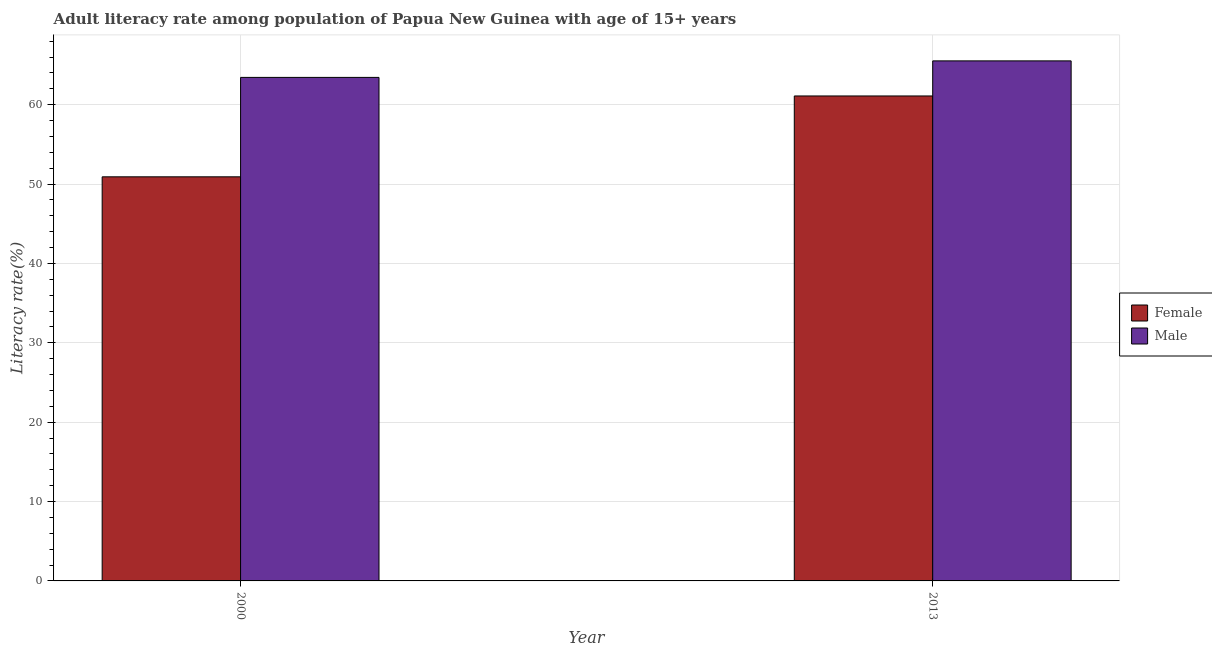How many groups of bars are there?
Your response must be concise. 2. Are the number of bars per tick equal to the number of legend labels?
Your answer should be very brief. Yes. Are the number of bars on each tick of the X-axis equal?
Your answer should be compact. Yes. In how many cases, is the number of bars for a given year not equal to the number of legend labels?
Provide a succinct answer. 0. What is the female adult literacy rate in 2000?
Your answer should be very brief. 50.92. Across all years, what is the maximum male adult literacy rate?
Provide a succinct answer. 65.53. Across all years, what is the minimum female adult literacy rate?
Provide a succinct answer. 50.92. In which year was the male adult literacy rate maximum?
Offer a terse response. 2013. What is the total male adult literacy rate in the graph?
Offer a terse response. 128.97. What is the difference between the female adult literacy rate in 2000 and that in 2013?
Make the answer very short. -10.19. What is the difference between the male adult literacy rate in 2013 and the female adult literacy rate in 2000?
Your answer should be compact. 2.08. What is the average female adult literacy rate per year?
Offer a very short reply. 56.01. In how many years, is the female adult literacy rate greater than 42 %?
Make the answer very short. 2. What is the ratio of the male adult literacy rate in 2000 to that in 2013?
Offer a very short reply. 0.97. What does the 2nd bar from the right in 2000 represents?
Your response must be concise. Female. How many bars are there?
Offer a terse response. 4. How many years are there in the graph?
Your answer should be very brief. 2. Are the values on the major ticks of Y-axis written in scientific E-notation?
Your response must be concise. No. Does the graph contain grids?
Your answer should be very brief. Yes. How many legend labels are there?
Provide a succinct answer. 2. How are the legend labels stacked?
Ensure brevity in your answer.  Vertical. What is the title of the graph?
Your answer should be compact. Adult literacy rate among population of Papua New Guinea with age of 15+ years. Does "Nonresident" appear as one of the legend labels in the graph?
Your response must be concise. No. What is the label or title of the X-axis?
Make the answer very short. Year. What is the label or title of the Y-axis?
Your answer should be very brief. Literacy rate(%). What is the Literacy rate(%) in Female in 2000?
Your answer should be very brief. 50.92. What is the Literacy rate(%) in Male in 2000?
Give a very brief answer. 63.45. What is the Literacy rate(%) of Female in 2013?
Your answer should be compact. 61.1. What is the Literacy rate(%) in Male in 2013?
Provide a succinct answer. 65.53. Across all years, what is the maximum Literacy rate(%) of Female?
Give a very brief answer. 61.1. Across all years, what is the maximum Literacy rate(%) in Male?
Provide a succinct answer. 65.53. Across all years, what is the minimum Literacy rate(%) in Female?
Offer a terse response. 50.92. Across all years, what is the minimum Literacy rate(%) of Male?
Your answer should be very brief. 63.45. What is the total Literacy rate(%) in Female in the graph?
Give a very brief answer. 112.02. What is the total Literacy rate(%) in Male in the graph?
Ensure brevity in your answer.  128.97. What is the difference between the Literacy rate(%) in Female in 2000 and that in 2013?
Offer a very short reply. -10.19. What is the difference between the Literacy rate(%) in Male in 2000 and that in 2013?
Give a very brief answer. -2.08. What is the difference between the Literacy rate(%) of Female in 2000 and the Literacy rate(%) of Male in 2013?
Your response must be concise. -14.61. What is the average Literacy rate(%) in Female per year?
Make the answer very short. 56.01. What is the average Literacy rate(%) of Male per year?
Offer a terse response. 64.49. In the year 2000, what is the difference between the Literacy rate(%) of Female and Literacy rate(%) of Male?
Ensure brevity in your answer.  -12.53. In the year 2013, what is the difference between the Literacy rate(%) in Female and Literacy rate(%) in Male?
Ensure brevity in your answer.  -4.42. What is the ratio of the Literacy rate(%) of Female in 2000 to that in 2013?
Provide a succinct answer. 0.83. What is the ratio of the Literacy rate(%) in Male in 2000 to that in 2013?
Make the answer very short. 0.97. What is the difference between the highest and the second highest Literacy rate(%) of Female?
Offer a terse response. 10.19. What is the difference between the highest and the second highest Literacy rate(%) in Male?
Your answer should be compact. 2.08. What is the difference between the highest and the lowest Literacy rate(%) of Female?
Your answer should be very brief. 10.19. What is the difference between the highest and the lowest Literacy rate(%) in Male?
Provide a short and direct response. 2.08. 